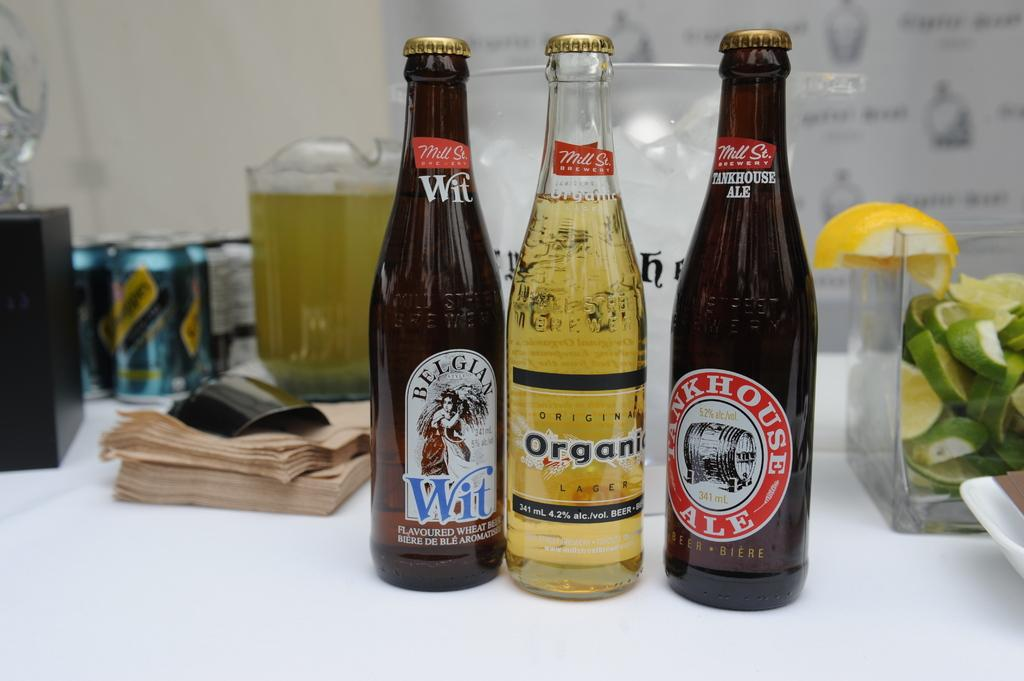<image>
Provide a brief description of the given image. A bottle of belgian wheat ale, organic lager, and bunkhouse ale lined up on a table. 